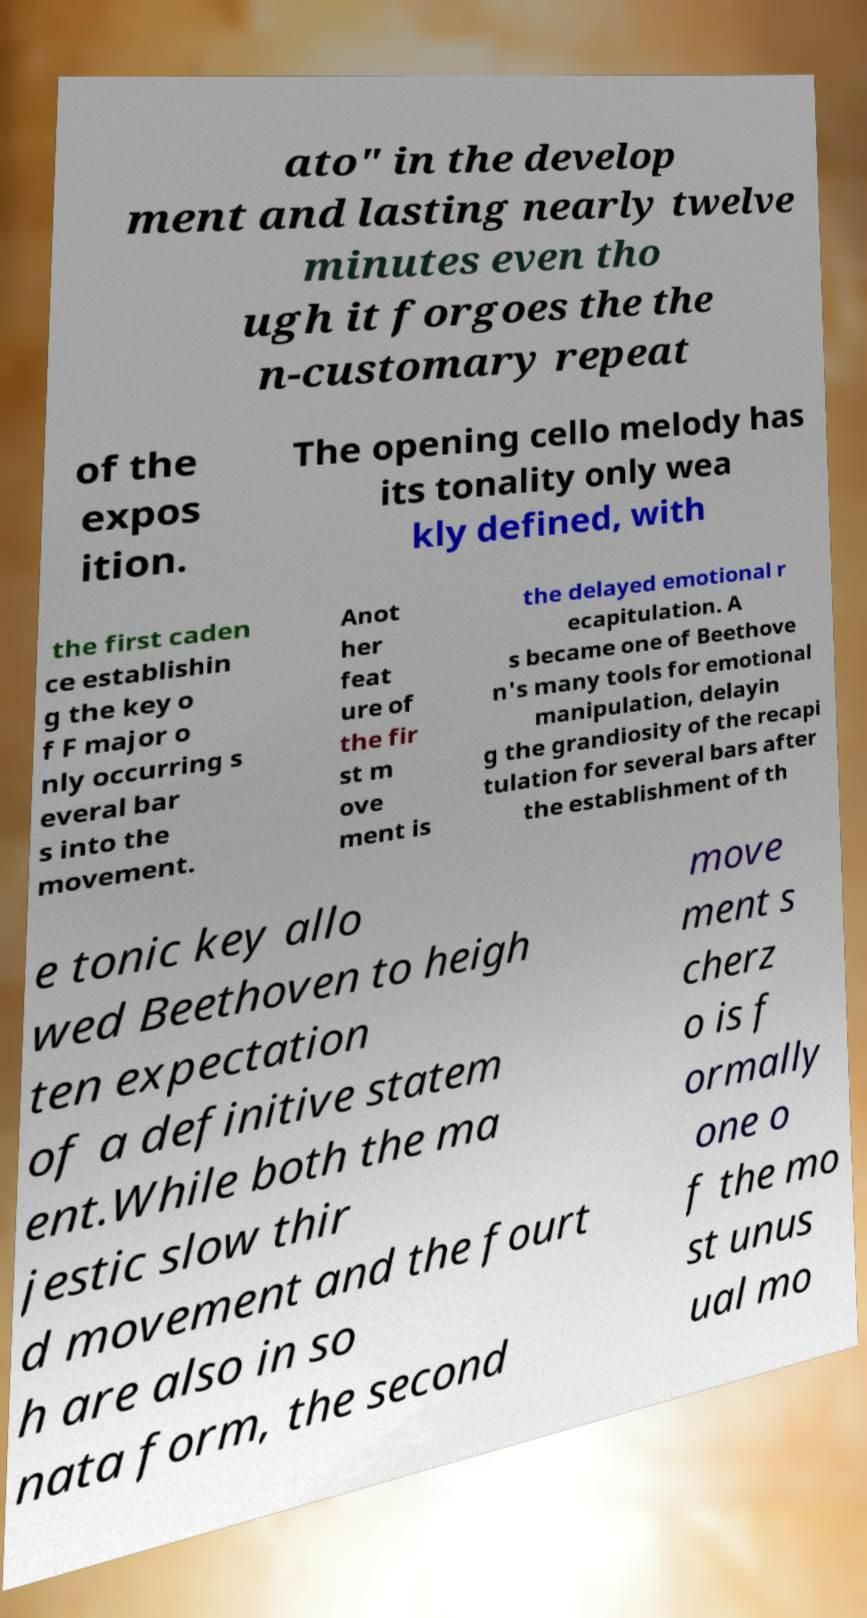Could you assist in decoding the text presented in this image and type it out clearly? ato" in the develop ment and lasting nearly twelve minutes even tho ugh it forgoes the the n-customary repeat of the expos ition. The opening cello melody has its tonality only wea kly defined, with the first caden ce establishin g the key o f F major o nly occurring s everal bar s into the movement. Anot her feat ure of the fir st m ove ment is the delayed emotional r ecapitulation. A s became one of Beethove n's many tools for emotional manipulation, delayin g the grandiosity of the recapi tulation for several bars after the establishment of th e tonic key allo wed Beethoven to heigh ten expectation of a definitive statem ent.While both the ma jestic slow thir d movement and the fourt h are also in so nata form, the second move ment s cherz o is f ormally one o f the mo st unus ual mo 